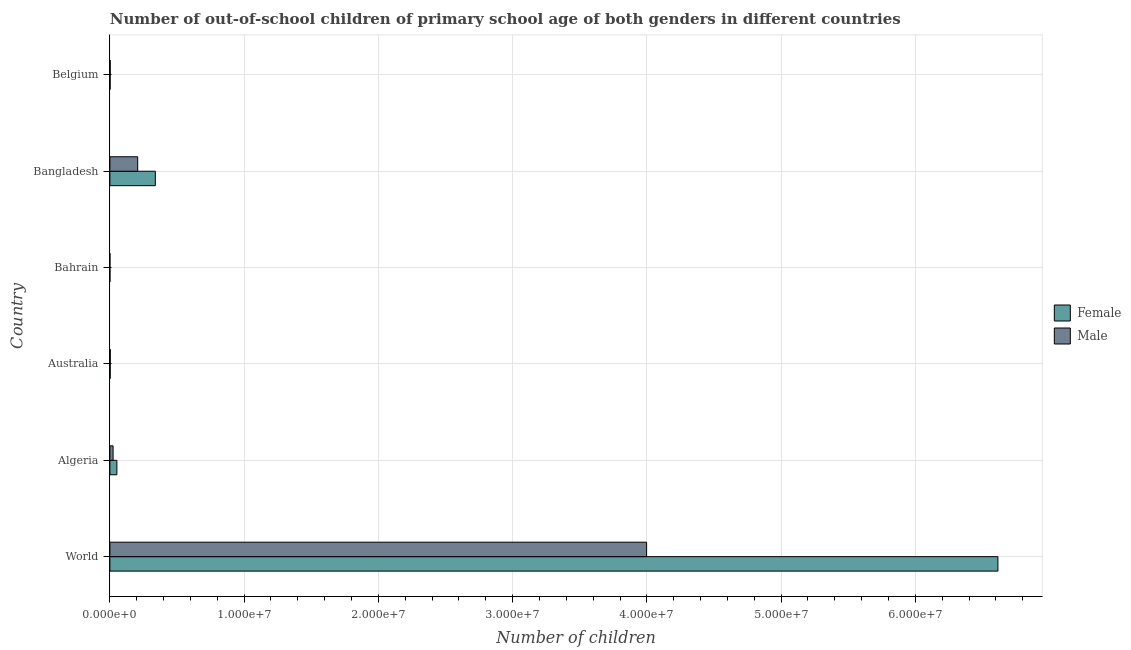Are the number of bars per tick equal to the number of legend labels?
Give a very brief answer. Yes. How many bars are there on the 6th tick from the top?
Provide a short and direct response. 2. How many bars are there on the 5th tick from the bottom?
Your answer should be compact. 2. In how many cases, is the number of bars for a given country not equal to the number of legend labels?
Provide a succinct answer. 0. What is the number of male out-of-school students in Australia?
Make the answer very short. 2.77e+04. Across all countries, what is the maximum number of male out-of-school students?
Keep it short and to the point. 4.00e+07. Across all countries, what is the minimum number of male out-of-school students?
Ensure brevity in your answer.  921. In which country was the number of female out-of-school students minimum?
Offer a very short reply. Bahrain. What is the total number of male out-of-school students in the graph?
Ensure brevity in your answer.  4.23e+07. What is the difference between the number of female out-of-school students in Australia and that in World?
Give a very brief answer. -6.61e+07. What is the difference between the number of female out-of-school students in Bangladesh and the number of male out-of-school students in Bahrain?
Give a very brief answer. 3.38e+06. What is the average number of female out-of-school students per country?
Offer a very short reply. 1.17e+07. What is the difference between the number of female out-of-school students and number of male out-of-school students in Belgium?
Your response must be concise. -5097. What is the ratio of the number of male out-of-school students in Algeria to that in Bahrain?
Provide a short and direct response. 259.4. Is the difference between the number of male out-of-school students in Bahrain and World greater than the difference between the number of female out-of-school students in Bahrain and World?
Provide a short and direct response. Yes. What is the difference between the highest and the second highest number of female out-of-school students?
Keep it short and to the point. 6.28e+07. What is the difference between the highest and the lowest number of male out-of-school students?
Ensure brevity in your answer.  4.00e+07. In how many countries, is the number of male out-of-school students greater than the average number of male out-of-school students taken over all countries?
Your answer should be very brief. 1. What does the 1st bar from the top in World represents?
Provide a short and direct response. Male. What is the difference between two consecutive major ticks on the X-axis?
Provide a succinct answer. 1.00e+07. Does the graph contain grids?
Make the answer very short. Yes. Where does the legend appear in the graph?
Your response must be concise. Center right. How are the legend labels stacked?
Your response must be concise. Vertical. What is the title of the graph?
Your answer should be very brief. Number of out-of-school children of primary school age of both genders in different countries. What is the label or title of the X-axis?
Offer a terse response. Number of children. What is the label or title of the Y-axis?
Offer a terse response. Country. What is the Number of children of Female in World?
Provide a short and direct response. 6.62e+07. What is the Number of children in Male in World?
Provide a short and direct response. 4.00e+07. What is the Number of children of Female in Algeria?
Give a very brief answer. 5.21e+05. What is the Number of children of Male in Algeria?
Make the answer very short. 2.39e+05. What is the Number of children in Female in Australia?
Make the answer very short. 2.33e+04. What is the Number of children of Male in Australia?
Provide a succinct answer. 2.77e+04. What is the Number of children in Female in Bahrain?
Offer a terse response. 1012. What is the Number of children of Male in Bahrain?
Your answer should be very brief. 921. What is the Number of children of Female in Bangladesh?
Your response must be concise. 3.38e+06. What is the Number of children of Male in Bangladesh?
Give a very brief answer. 2.07e+06. What is the Number of children in Female in Belgium?
Ensure brevity in your answer.  1.80e+04. What is the Number of children in Male in Belgium?
Your answer should be very brief. 2.31e+04. Across all countries, what is the maximum Number of children of Female?
Give a very brief answer. 6.62e+07. Across all countries, what is the maximum Number of children in Male?
Keep it short and to the point. 4.00e+07. Across all countries, what is the minimum Number of children in Female?
Offer a very short reply. 1012. Across all countries, what is the minimum Number of children in Male?
Your answer should be compact. 921. What is the total Number of children in Female in the graph?
Your answer should be very brief. 7.01e+07. What is the total Number of children in Male in the graph?
Make the answer very short. 4.23e+07. What is the difference between the Number of children of Female in World and that in Algeria?
Your response must be concise. 6.56e+07. What is the difference between the Number of children in Male in World and that in Algeria?
Ensure brevity in your answer.  3.97e+07. What is the difference between the Number of children in Female in World and that in Australia?
Offer a very short reply. 6.61e+07. What is the difference between the Number of children of Male in World and that in Australia?
Provide a short and direct response. 4.00e+07. What is the difference between the Number of children of Female in World and that in Bahrain?
Offer a terse response. 6.62e+07. What is the difference between the Number of children of Male in World and that in Bahrain?
Provide a succinct answer. 4.00e+07. What is the difference between the Number of children of Female in World and that in Bangladesh?
Ensure brevity in your answer.  6.28e+07. What is the difference between the Number of children in Male in World and that in Bangladesh?
Your answer should be compact. 3.79e+07. What is the difference between the Number of children in Female in World and that in Belgium?
Your response must be concise. 6.61e+07. What is the difference between the Number of children in Male in World and that in Belgium?
Offer a terse response. 4.00e+07. What is the difference between the Number of children of Female in Algeria and that in Australia?
Ensure brevity in your answer.  4.97e+05. What is the difference between the Number of children of Male in Algeria and that in Australia?
Provide a succinct answer. 2.11e+05. What is the difference between the Number of children in Female in Algeria and that in Bahrain?
Give a very brief answer. 5.19e+05. What is the difference between the Number of children in Male in Algeria and that in Bahrain?
Keep it short and to the point. 2.38e+05. What is the difference between the Number of children in Female in Algeria and that in Bangladesh?
Provide a succinct answer. -2.86e+06. What is the difference between the Number of children in Male in Algeria and that in Bangladesh?
Provide a short and direct response. -1.83e+06. What is the difference between the Number of children of Female in Algeria and that in Belgium?
Provide a succinct answer. 5.03e+05. What is the difference between the Number of children of Male in Algeria and that in Belgium?
Ensure brevity in your answer.  2.16e+05. What is the difference between the Number of children in Female in Australia and that in Bahrain?
Your answer should be very brief. 2.23e+04. What is the difference between the Number of children in Male in Australia and that in Bahrain?
Your answer should be very brief. 2.68e+04. What is the difference between the Number of children of Female in Australia and that in Bangladesh?
Keep it short and to the point. -3.36e+06. What is the difference between the Number of children in Male in Australia and that in Bangladesh?
Your response must be concise. -2.04e+06. What is the difference between the Number of children of Female in Australia and that in Belgium?
Your answer should be compact. 5326. What is the difference between the Number of children of Male in Australia and that in Belgium?
Keep it short and to the point. 4636. What is the difference between the Number of children of Female in Bahrain and that in Bangladesh?
Offer a terse response. -3.38e+06. What is the difference between the Number of children of Male in Bahrain and that in Bangladesh?
Make the answer very short. -2.07e+06. What is the difference between the Number of children in Female in Bahrain and that in Belgium?
Your answer should be very brief. -1.70e+04. What is the difference between the Number of children of Male in Bahrain and that in Belgium?
Keep it short and to the point. -2.21e+04. What is the difference between the Number of children of Female in Bangladesh and that in Belgium?
Provide a short and direct response. 3.37e+06. What is the difference between the Number of children of Male in Bangladesh and that in Belgium?
Make the answer very short. 2.05e+06. What is the difference between the Number of children of Female in World and the Number of children of Male in Algeria?
Your answer should be compact. 6.59e+07. What is the difference between the Number of children of Female in World and the Number of children of Male in Australia?
Provide a short and direct response. 6.61e+07. What is the difference between the Number of children of Female in World and the Number of children of Male in Bahrain?
Ensure brevity in your answer.  6.62e+07. What is the difference between the Number of children in Female in World and the Number of children in Male in Bangladesh?
Offer a terse response. 6.41e+07. What is the difference between the Number of children of Female in World and the Number of children of Male in Belgium?
Offer a terse response. 6.61e+07. What is the difference between the Number of children of Female in Algeria and the Number of children of Male in Australia?
Offer a terse response. 4.93e+05. What is the difference between the Number of children of Female in Algeria and the Number of children of Male in Bahrain?
Keep it short and to the point. 5.20e+05. What is the difference between the Number of children of Female in Algeria and the Number of children of Male in Bangladesh?
Provide a succinct answer. -1.55e+06. What is the difference between the Number of children in Female in Algeria and the Number of children in Male in Belgium?
Your answer should be very brief. 4.97e+05. What is the difference between the Number of children in Female in Australia and the Number of children in Male in Bahrain?
Offer a very short reply. 2.24e+04. What is the difference between the Number of children of Female in Australia and the Number of children of Male in Bangladesh?
Offer a terse response. -2.05e+06. What is the difference between the Number of children of Female in Australia and the Number of children of Male in Belgium?
Make the answer very short. 229. What is the difference between the Number of children of Female in Bahrain and the Number of children of Male in Bangladesh?
Make the answer very short. -2.07e+06. What is the difference between the Number of children in Female in Bahrain and the Number of children in Male in Belgium?
Offer a terse response. -2.20e+04. What is the difference between the Number of children in Female in Bangladesh and the Number of children in Male in Belgium?
Make the answer very short. 3.36e+06. What is the average Number of children in Female per country?
Your answer should be compact. 1.17e+07. What is the average Number of children of Male per country?
Provide a short and direct response. 7.06e+06. What is the difference between the Number of children in Female and Number of children in Male in World?
Keep it short and to the point. 2.62e+07. What is the difference between the Number of children of Female and Number of children of Male in Algeria?
Offer a terse response. 2.82e+05. What is the difference between the Number of children of Female and Number of children of Male in Australia?
Provide a succinct answer. -4407. What is the difference between the Number of children of Female and Number of children of Male in Bahrain?
Ensure brevity in your answer.  91. What is the difference between the Number of children in Female and Number of children in Male in Bangladesh?
Offer a very short reply. 1.31e+06. What is the difference between the Number of children of Female and Number of children of Male in Belgium?
Your response must be concise. -5097. What is the ratio of the Number of children in Female in World to that in Algeria?
Give a very brief answer. 127.09. What is the ratio of the Number of children of Male in World to that in Algeria?
Make the answer very short. 167.35. What is the ratio of the Number of children in Female in World to that in Australia?
Your answer should be compact. 2840.59. What is the ratio of the Number of children of Male in World to that in Australia?
Ensure brevity in your answer.  1443.64. What is the ratio of the Number of children of Female in World to that in Bahrain?
Offer a terse response. 6.54e+04. What is the ratio of the Number of children of Male in World to that in Bahrain?
Your answer should be compact. 4.34e+04. What is the ratio of the Number of children in Female in World to that in Bangladesh?
Give a very brief answer. 19.54. What is the ratio of the Number of children of Male in World to that in Bangladesh?
Give a very brief answer. 19.29. What is the ratio of the Number of children of Female in World to that in Belgium?
Provide a succinct answer. 3682.86. What is the ratio of the Number of children in Male in World to that in Belgium?
Your answer should be very brief. 1733.89. What is the ratio of the Number of children of Female in Algeria to that in Australia?
Your response must be concise. 22.35. What is the ratio of the Number of children in Male in Algeria to that in Australia?
Make the answer very short. 8.63. What is the ratio of the Number of children in Female in Algeria to that in Bahrain?
Give a very brief answer. 514.34. What is the ratio of the Number of children in Male in Algeria to that in Bahrain?
Your response must be concise. 259.4. What is the ratio of the Number of children in Female in Algeria to that in Bangladesh?
Make the answer very short. 0.15. What is the ratio of the Number of children in Male in Algeria to that in Bangladesh?
Provide a short and direct response. 0.12. What is the ratio of the Number of children in Female in Algeria to that in Belgium?
Your answer should be compact. 28.98. What is the ratio of the Number of children in Male in Algeria to that in Belgium?
Ensure brevity in your answer.  10.36. What is the ratio of the Number of children of Female in Australia to that in Bahrain?
Give a very brief answer. 23.01. What is the ratio of the Number of children in Male in Australia to that in Bahrain?
Your answer should be compact. 30.07. What is the ratio of the Number of children in Female in Australia to that in Bangladesh?
Provide a short and direct response. 0.01. What is the ratio of the Number of children in Male in Australia to that in Bangladesh?
Give a very brief answer. 0.01. What is the ratio of the Number of children in Female in Australia to that in Belgium?
Provide a succinct answer. 1.3. What is the ratio of the Number of children in Male in Australia to that in Belgium?
Ensure brevity in your answer.  1.2. What is the ratio of the Number of children of Male in Bahrain to that in Bangladesh?
Your answer should be very brief. 0. What is the ratio of the Number of children in Female in Bahrain to that in Belgium?
Ensure brevity in your answer.  0.06. What is the ratio of the Number of children of Male in Bahrain to that in Belgium?
Your response must be concise. 0.04. What is the ratio of the Number of children in Female in Bangladesh to that in Belgium?
Your answer should be compact. 188.45. What is the ratio of the Number of children of Male in Bangladesh to that in Belgium?
Provide a short and direct response. 89.86. What is the difference between the highest and the second highest Number of children in Female?
Offer a very short reply. 6.28e+07. What is the difference between the highest and the second highest Number of children of Male?
Your answer should be compact. 3.79e+07. What is the difference between the highest and the lowest Number of children in Female?
Your answer should be compact. 6.62e+07. What is the difference between the highest and the lowest Number of children of Male?
Make the answer very short. 4.00e+07. 